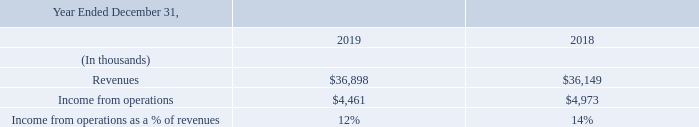Europe
Europe net revenues increased $749,000 in 2019 compared to 2018 (see “Revenues” above). Europe expenses increased $1.3 million from 2018 to 2019 primarily due to increased marketing costs.
Foreign currency movements relative to the U.S. dollar negatively impacted our local currency income from our operations in Europe by approximately $207,000 and $181,000 for 2019 and 2018, respectively.
What is the revenue amount in 2019 and 2018 respectively?
Answer scale should be: thousand. $36,898, $36,149. What is the income from operations in 2019 and 2018 respectively?
Answer scale should be: thousand. $4,461, $4,973. Why did Europe expenses increase from 2018 to 2019? Primarily due to increased marketing costs. What is the average income from operations in 2018 and 2019?
Answer scale should be: thousand. (4,461+ 4,973)/2
Answer: 4717. What is the change in income from operations between 2018 and 2019?
Answer scale should be: thousand. 4,461-4,973
Answer: -512. What is the percentage change in revenues from 2018 to 2019?
Answer scale should be: percent. (36,898-36,149)/36,149
Answer: 2.07. 